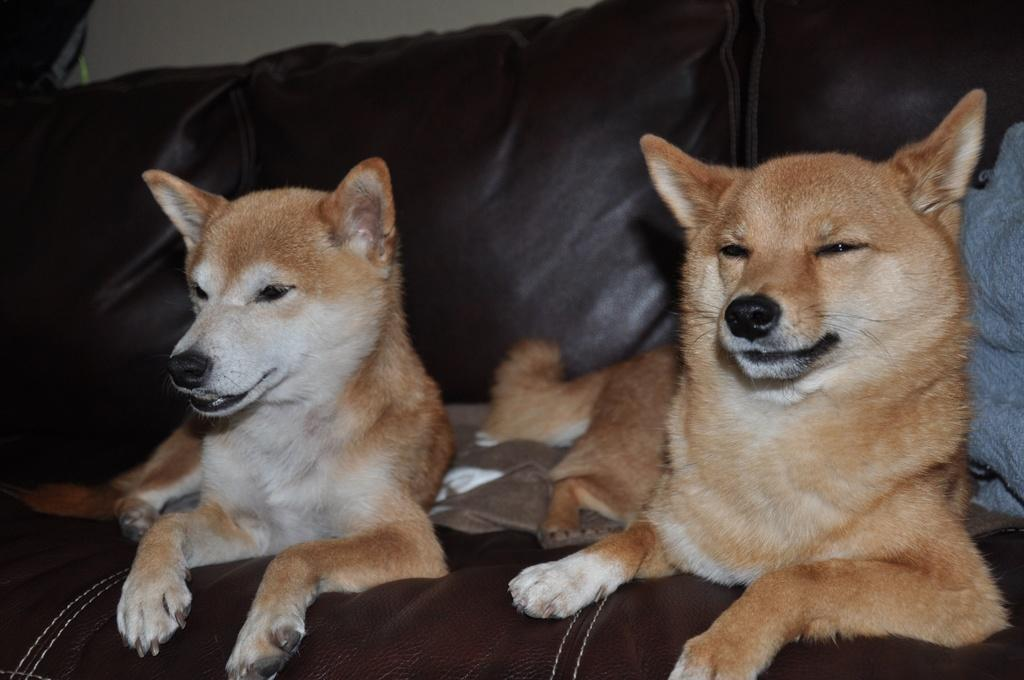What type of animals are on the sofa in the image? There are dogs on the sofa in the image. What can be seen on the right side of the image? There is cloth on the right side of the image. What is visible in the background of the image? There is a wall visible in the image. What type of lunchroom can be seen in the image? There is no lunchroom present in the image. 